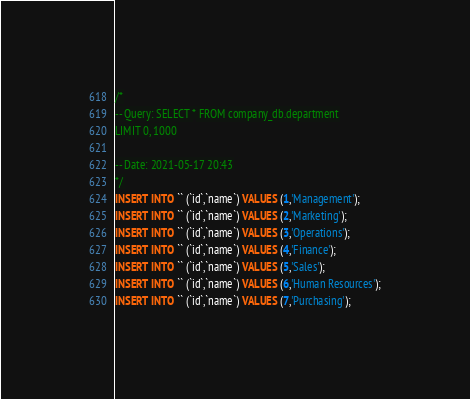Convert code to text. <code><loc_0><loc_0><loc_500><loc_500><_SQL_>/*
-- Query: SELECT * FROM company_db.department
LIMIT 0, 1000

-- Date: 2021-05-17 20:43
*/
INSERT INTO `` (`id`,`name`) VALUES (1,'Management');
INSERT INTO `` (`id`,`name`) VALUES (2,'Marketing');
INSERT INTO `` (`id`,`name`) VALUES (3,'Operations');
INSERT INTO `` (`id`,`name`) VALUES (4,'Finance');
INSERT INTO `` (`id`,`name`) VALUES (5,'Sales');
INSERT INTO `` (`id`,`name`) VALUES (6,'Human Resources');
INSERT INTO `` (`id`,`name`) VALUES (7,'Purchasing');
</code> 